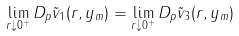Convert formula to latex. <formula><loc_0><loc_0><loc_500><loc_500>\lim _ { r \downarrow 0 ^ { + } } D _ { p } \tilde { v } _ { 1 } ( r , y _ { m } ) = \lim _ { r \downarrow 0 ^ { + } } D _ { p } \tilde { v } _ { 3 } ( r , y _ { m } )</formula> 